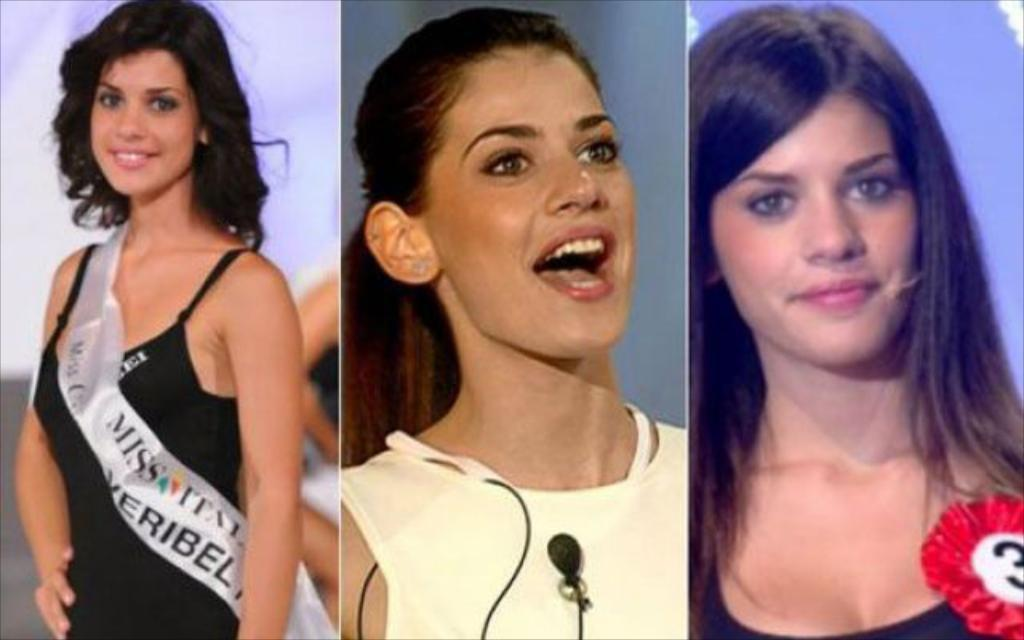How many women are present in the image? There are three women in the image. What are the women wearing? The women are wearing clothes. What can be seen in the background of the image? There is a banner in the image. What object might be used for amplifying sound in the image? There is a microphone in the image. What is the object that appears to be a collection of items in the image? There is a batch in the image. How many spiders are crawling on the women in the image? There are no spiders present in the image; the women are not interacting with any spiders. What type of glue is being used to hold the banner in the image? There is no glue visible in the image, and the banner's method of attachment is not mentioned. 